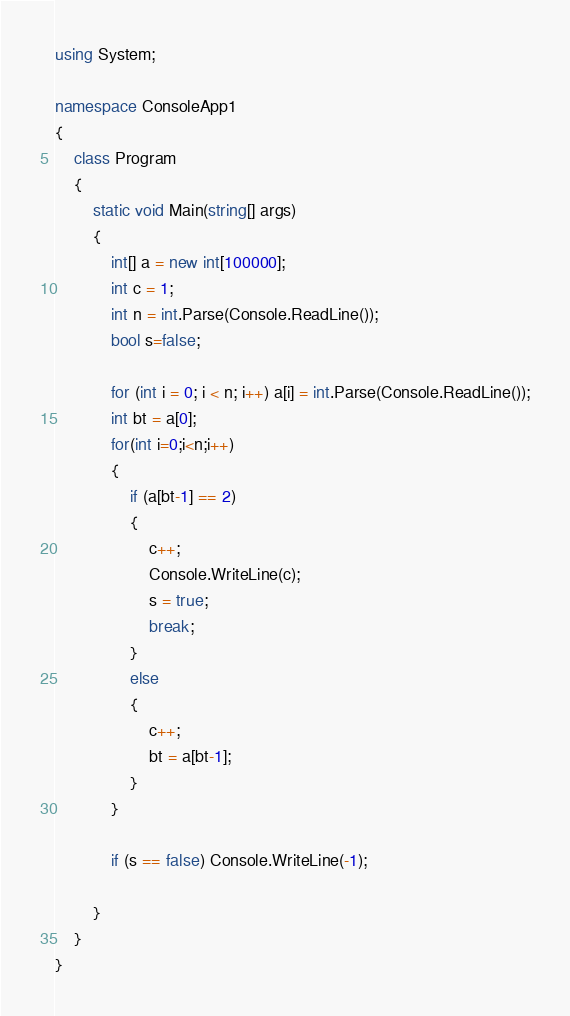<code> <loc_0><loc_0><loc_500><loc_500><_C#_>using System;

namespace ConsoleApp1
{
    class Program
    {
        static void Main(string[] args)
        {
            int[] a = new int[100000];
            int c = 1;
            int n = int.Parse(Console.ReadLine());
            bool s=false;

            for (int i = 0; i < n; i++) a[i] = int.Parse(Console.ReadLine());
            int bt = a[0];
            for(int i=0;i<n;i++)
            {
                if (a[bt-1] == 2)
                {
                    c++;
                    Console.WriteLine(c);
                    s = true;
                    break;
                }
                else
                {
                    c++;
                    bt = a[bt-1];
                }
            }

            if (s == false) Console.WriteLine(-1);

        }
    }
}
</code> 